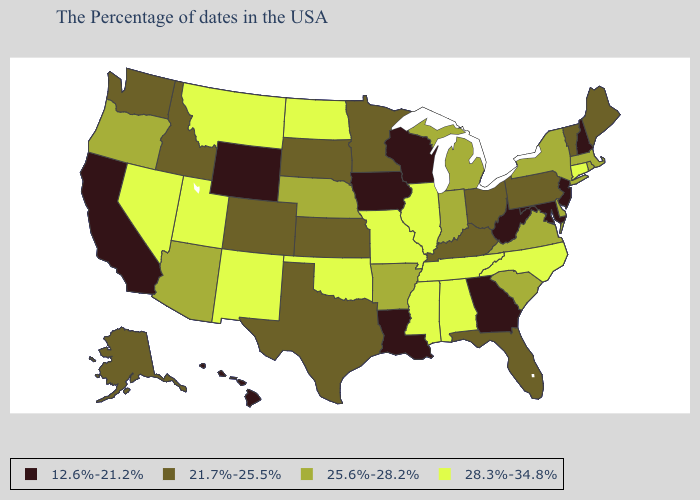What is the value of Indiana?
Short answer required. 25.6%-28.2%. What is the highest value in states that border Washington?
Give a very brief answer. 25.6%-28.2%. What is the lowest value in the MidWest?
Give a very brief answer. 12.6%-21.2%. What is the lowest value in the USA?
Answer briefly. 12.6%-21.2%. Name the states that have a value in the range 25.6%-28.2%?
Keep it brief. Massachusetts, Rhode Island, New York, Delaware, Virginia, South Carolina, Michigan, Indiana, Arkansas, Nebraska, Arizona, Oregon. Does Virginia have a higher value than New Jersey?
Answer briefly. Yes. Does Nevada have the lowest value in the USA?
Quick response, please. No. What is the highest value in the South ?
Concise answer only. 28.3%-34.8%. What is the value of Rhode Island?
Keep it brief. 25.6%-28.2%. Does Connecticut have the same value as Nevada?
Write a very short answer. Yes. What is the value of Kentucky?
Quick response, please. 21.7%-25.5%. What is the highest value in the West ?
Quick response, please. 28.3%-34.8%. Does Iowa have the lowest value in the MidWest?
Quick response, please. Yes. What is the value of New York?
Concise answer only. 25.6%-28.2%. What is the value of Iowa?
Write a very short answer. 12.6%-21.2%. 